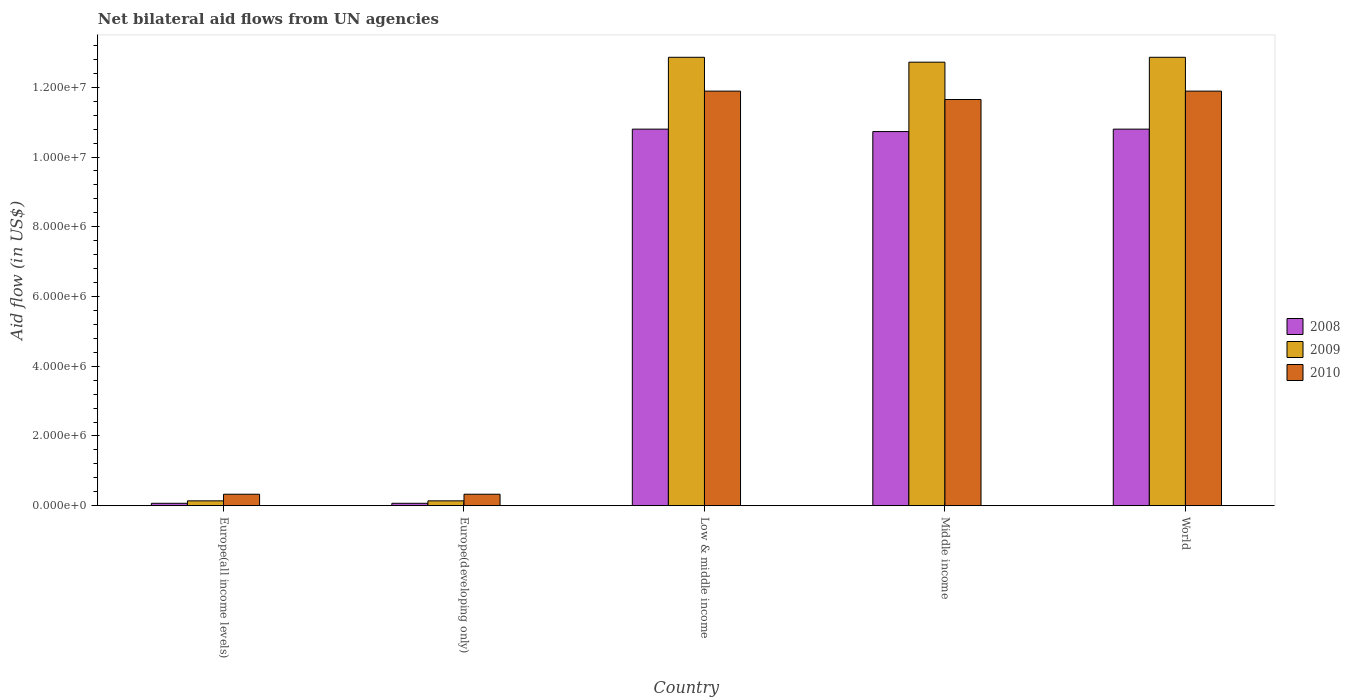How many different coloured bars are there?
Your answer should be compact. 3. How many groups of bars are there?
Ensure brevity in your answer.  5. Are the number of bars on each tick of the X-axis equal?
Ensure brevity in your answer.  Yes. What is the label of the 1st group of bars from the left?
Ensure brevity in your answer.  Europe(all income levels). In how many cases, is the number of bars for a given country not equal to the number of legend labels?
Offer a very short reply. 0. Across all countries, what is the maximum net bilateral aid flow in 2009?
Provide a succinct answer. 1.29e+07. In which country was the net bilateral aid flow in 2008 minimum?
Make the answer very short. Europe(all income levels). What is the total net bilateral aid flow in 2008 in the graph?
Ensure brevity in your answer.  3.25e+07. What is the difference between the net bilateral aid flow in 2008 in Europe(developing only) and that in World?
Keep it short and to the point. -1.07e+07. What is the difference between the net bilateral aid flow in 2010 in World and the net bilateral aid flow in 2008 in Europe(all income levels)?
Give a very brief answer. 1.18e+07. What is the average net bilateral aid flow in 2009 per country?
Your answer should be very brief. 7.74e+06. What is the difference between the net bilateral aid flow of/in 2010 and net bilateral aid flow of/in 2009 in World?
Provide a short and direct response. -9.70e+05. What is the ratio of the net bilateral aid flow in 2008 in Europe(developing only) to that in World?
Offer a terse response. 0.01. Is the net bilateral aid flow in 2010 in Low & middle income less than that in Middle income?
Ensure brevity in your answer.  No. What is the difference between the highest and the lowest net bilateral aid flow in 2010?
Provide a short and direct response. 1.16e+07. How many countries are there in the graph?
Ensure brevity in your answer.  5. What is the difference between two consecutive major ticks on the Y-axis?
Provide a short and direct response. 2.00e+06. Does the graph contain any zero values?
Offer a terse response. No. Does the graph contain grids?
Keep it short and to the point. No. Where does the legend appear in the graph?
Your answer should be very brief. Center right. How are the legend labels stacked?
Keep it short and to the point. Vertical. What is the title of the graph?
Your answer should be very brief. Net bilateral aid flows from UN agencies. Does "1962" appear as one of the legend labels in the graph?
Provide a short and direct response. No. What is the label or title of the Y-axis?
Ensure brevity in your answer.  Aid flow (in US$). What is the Aid flow (in US$) of 2008 in Europe(all income levels)?
Provide a short and direct response. 7.00e+04. What is the Aid flow (in US$) in 2010 in Europe(all income levels)?
Offer a terse response. 3.30e+05. What is the Aid flow (in US$) in 2008 in Europe(developing only)?
Your response must be concise. 7.00e+04. What is the Aid flow (in US$) of 2009 in Europe(developing only)?
Your answer should be very brief. 1.40e+05. What is the Aid flow (in US$) of 2010 in Europe(developing only)?
Offer a terse response. 3.30e+05. What is the Aid flow (in US$) in 2008 in Low & middle income?
Provide a succinct answer. 1.08e+07. What is the Aid flow (in US$) in 2009 in Low & middle income?
Keep it short and to the point. 1.29e+07. What is the Aid flow (in US$) of 2010 in Low & middle income?
Ensure brevity in your answer.  1.19e+07. What is the Aid flow (in US$) in 2008 in Middle income?
Provide a short and direct response. 1.07e+07. What is the Aid flow (in US$) of 2009 in Middle income?
Provide a succinct answer. 1.27e+07. What is the Aid flow (in US$) in 2010 in Middle income?
Make the answer very short. 1.16e+07. What is the Aid flow (in US$) in 2008 in World?
Your response must be concise. 1.08e+07. What is the Aid flow (in US$) in 2009 in World?
Offer a very short reply. 1.29e+07. What is the Aid flow (in US$) of 2010 in World?
Offer a very short reply. 1.19e+07. Across all countries, what is the maximum Aid flow (in US$) in 2008?
Keep it short and to the point. 1.08e+07. Across all countries, what is the maximum Aid flow (in US$) of 2009?
Your response must be concise. 1.29e+07. Across all countries, what is the maximum Aid flow (in US$) of 2010?
Provide a succinct answer. 1.19e+07. Across all countries, what is the minimum Aid flow (in US$) in 2010?
Offer a very short reply. 3.30e+05. What is the total Aid flow (in US$) in 2008 in the graph?
Provide a short and direct response. 3.25e+07. What is the total Aid flow (in US$) of 2009 in the graph?
Make the answer very short. 3.87e+07. What is the total Aid flow (in US$) in 2010 in the graph?
Provide a short and direct response. 3.61e+07. What is the difference between the Aid flow (in US$) of 2008 in Europe(all income levels) and that in Europe(developing only)?
Keep it short and to the point. 0. What is the difference between the Aid flow (in US$) in 2008 in Europe(all income levels) and that in Low & middle income?
Give a very brief answer. -1.07e+07. What is the difference between the Aid flow (in US$) in 2009 in Europe(all income levels) and that in Low & middle income?
Your answer should be compact. -1.27e+07. What is the difference between the Aid flow (in US$) of 2010 in Europe(all income levels) and that in Low & middle income?
Offer a very short reply. -1.16e+07. What is the difference between the Aid flow (in US$) of 2008 in Europe(all income levels) and that in Middle income?
Your answer should be compact. -1.07e+07. What is the difference between the Aid flow (in US$) of 2009 in Europe(all income levels) and that in Middle income?
Your answer should be compact. -1.26e+07. What is the difference between the Aid flow (in US$) of 2010 in Europe(all income levels) and that in Middle income?
Provide a succinct answer. -1.13e+07. What is the difference between the Aid flow (in US$) in 2008 in Europe(all income levels) and that in World?
Offer a very short reply. -1.07e+07. What is the difference between the Aid flow (in US$) in 2009 in Europe(all income levels) and that in World?
Ensure brevity in your answer.  -1.27e+07. What is the difference between the Aid flow (in US$) of 2010 in Europe(all income levels) and that in World?
Provide a short and direct response. -1.16e+07. What is the difference between the Aid flow (in US$) in 2008 in Europe(developing only) and that in Low & middle income?
Your answer should be very brief. -1.07e+07. What is the difference between the Aid flow (in US$) of 2009 in Europe(developing only) and that in Low & middle income?
Offer a very short reply. -1.27e+07. What is the difference between the Aid flow (in US$) in 2010 in Europe(developing only) and that in Low & middle income?
Your response must be concise. -1.16e+07. What is the difference between the Aid flow (in US$) in 2008 in Europe(developing only) and that in Middle income?
Offer a very short reply. -1.07e+07. What is the difference between the Aid flow (in US$) in 2009 in Europe(developing only) and that in Middle income?
Provide a succinct answer. -1.26e+07. What is the difference between the Aid flow (in US$) in 2010 in Europe(developing only) and that in Middle income?
Your response must be concise. -1.13e+07. What is the difference between the Aid flow (in US$) of 2008 in Europe(developing only) and that in World?
Keep it short and to the point. -1.07e+07. What is the difference between the Aid flow (in US$) of 2009 in Europe(developing only) and that in World?
Your answer should be very brief. -1.27e+07. What is the difference between the Aid flow (in US$) of 2010 in Europe(developing only) and that in World?
Make the answer very short. -1.16e+07. What is the difference between the Aid flow (in US$) in 2008 in Low & middle income and that in World?
Provide a succinct answer. 0. What is the difference between the Aid flow (in US$) in 2009 in Low & middle income and that in World?
Keep it short and to the point. 0. What is the difference between the Aid flow (in US$) of 2008 in Middle income and that in World?
Ensure brevity in your answer.  -7.00e+04. What is the difference between the Aid flow (in US$) in 2009 in Middle income and that in World?
Your response must be concise. -1.40e+05. What is the difference between the Aid flow (in US$) of 2010 in Middle income and that in World?
Make the answer very short. -2.40e+05. What is the difference between the Aid flow (in US$) in 2008 in Europe(all income levels) and the Aid flow (in US$) in 2009 in Europe(developing only)?
Provide a short and direct response. -7.00e+04. What is the difference between the Aid flow (in US$) in 2009 in Europe(all income levels) and the Aid flow (in US$) in 2010 in Europe(developing only)?
Provide a succinct answer. -1.90e+05. What is the difference between the Aid flow (in US$) of 2008 in Europe(all income levels) and the Aid flow (in US$) of 2009 in Low & middle income?
Offer a very short reply. -1.28e+07. What is the difference between the Aid flow (in US$) of 2008 in Europe(all income levels) and the Aid flow (in US$) of 2010 in Low & middle income?
Ensure brevity in your answer.  -1.18e+07. What is the difference between the Aid flow (in US$) in 2009 in Europe(all income levels) and the Aid flow (in US$) in 2010 in Low & middle income?
Provide a succinct answer. -1.18e+07. What is the difference between the Aid flow (in US$) in 2008 in Europe(all income levels) and the Aid flow (in US$) in 2009 in Middle income?
Make the answer very short. -1.26e+07. What is the difference between the Aid flow (in US$) of 2008 in Europe(all income levels) and the Aid flow (in US$) of 2010 in Middle income?
Provide a succinct answer. -1.16e+07. What is the difference between the Aid flow (in US$) in 2009 in Europe(all income levels) and the Aid flow (in US$) in 2010 in Middle income?
Provide a succinct answer. -1.15e+07. What is the difference between the Aid flow (in US$) in 2008 in Europe(all income levels) and the Aid flow (in US$) in 2009 in World?
Provide a short and direct response. -1.28e+07. What is the difference between the Aid flow (in US$) of 2008 in Europe(all income levels) and the Aid flow (in US$) of 2010 in World?
Provide a succinct answer. -1.18e+07. What is the difference between the Aid flow (in US$) of 2009 in Europe(all income levels) and the Aid flow (in US$) of 2010 in World?
Give a very brief answer. -1.18e+07. What is the difference between the Aid flow (in US$) in 2008 in Europe(developing only) and the Aid flow (in US$) in 2009 in Low & middle income?
Give a very brief answer. -1.28e+07. What is the difference between the Aid flow (in US$) of 2008 in Europe(developing only) and the Aid flow (in US$) of 2010 in Low & middle income?
Ensure brevity in your answer.  -1.18e+07. What is the difference between the Aid flow (in US$) in 2009 in Europe(developing only) and the Aid flow (in US$) in 2010 in Low & middle income?
Your answer should be very brief. -1.18e+07. What is the difference between the Aid flow (in US$) in 2008 in Europe(developing only) and the Aid flow (in US$) in 2009 in Middle income?
Provide a short and direct response. -1.26e+07. What is the difference between the Aid flow (in US$) in 2008 in Europe(developing only) and the Aid flow (in US$) in 2010 in Middle income?
Give a very brief answer. -1.16e+07. What is the difference between the Aid flow (in US$) in 2009 in Europe(developing only) and the Aid flow (in US$) in 2010 in Middle income?
Make the answer very short. -1.15e+07. What is the difference between the Aid flow (in US$) in 2008 in Europe(developing only) and the Aid flow (in US$) in 2009 in World?
Offer a very short reply. -1.28e+07. What is the difference between the Aid flow (in US$) in 2008 in Europe(developing only) and the Aid flow (in US$) in 2010 in World?
Keep it short and to the point. -1.18e+07. What is the difference between the Aid flow (in US$) in 2009 in Europe(developing only) and the Aid flow (in US$) in 2010 in World?
Your answer should be compact. -1.18e+07. What is the difference between the Aid flow (in US$) of 2008 in Low & middle income and the Aid flow (in US$) of 2009 in Middle income?
Provide a short and direct response. -1.92e+06. What is the difference between the Aid flow (in US$) of 2008 in Low & middle income and the Aid flow (in US$) of 2010 in Middle income?
Provide a short and direct response. -8.50e+05. What is the difference between the Aid flow (in US$) of 2009 in Low & middle income and the Aid flow (in US$) of 2010 in Middle income?
Provide a succinct answer. 1.21e+06. What is the difference between the Aid flow (in US$) of 2008 in Low & middle income and the Aid flow (in US$) of 2009 in World?
Your answer should be very brief. -2.06e+06. What is the difference between the Aid flow (in US$) in 2008 in Low & middle income and the Aid flow (in US$) in 2010 in World?
Provide a short and direct response. -1.09e+06. What is the difference between the Aid flow (in US$) of 2009 in Low & middle income and the Aid flow (in US$) of 2010 in World?
Your response must be concise. 9.70e+05. What is the difference between the Aid flow (in US$) of 2008 in Middle income and the Aid flow (in US$) of 2009 in World?
Your answer should be very brief. -2.13e+06. What is the difference between the Aid flow (in US$) in 2008 in Middle income and the Aid flow (in US$) in 2010 in World?
Keep it short and to the point. -1.16e+06. What is the difference between the Aid flow (in US$) of 2009 in Middle income and the Aid flow (in US$) of 2010 in World?
Ensure brevity in your answer.  8.30e+05. What is the average Aid flow (in US$) in 2008 per country?
Provide a short and direct response. 6.49e+06. What is the average Aid flow (in US$) of 2009 per country?
Give a very brief answer. 7.74e+06. What is the average Aid flow (in US$) of 2010 per country?
Your answer should be compact. 7.22e+06. What is the difference between the Aid flow (in US$) of 2008 and Aid flow (in US$) of 2010 in Europe(all income levels)?
Ensure brevity in your answer.  -2.60e+05. What is the difference between the Aid flow (in US$) in 2008 and Aid flow (in US$) in 2010 in Europe(developing only)?
Provide a succinct answer. -2.60e+05. What is the difference between the Aid flow (in US$) of 2009 and Aid flow (in US$) of 2010 in Europe(developing only)?
Offer a very short reply. -1.90e+05. What is the difference between the Aid flow (in US$) of 2008 and Aid flow (in US$) of 2009 in Low & middle income?
Offer a very short reply. -2.06e+06. What is the difference between the Aid flow (in US$) of 2008 and Aid flow (in US$) of 2010 in Low & middle income?
Ensure brevity in your answer.  -1.09e+06. What is the difference between the Aid flow (in US$) in 2009 and Aid flow (in US$) in 2010 in Low & middle income?
Offer a terse response. 9.70e+05. What is the difference between the Aid flow (in US$) of 2008 and Aid flow (in US$) of 2009 in Middle income?
Your response must be concise. -1.99e+06. What is the difference between the Aid flow (in US$) in 2008 and Aid flow (in US$) in 2010 in Middle income?
Provide a succinct answer. -9.20e+05. What is the difference between the Aid flow (in US$) in 2009 and Aid flow (in US$) in 2010 in Middle income?
Your answer should be very brief. 1.07e+06. What is the difference between the Aid flow (in US$) of 2008 and Aid flow (in US$) of 2009 in World?
Your answer should be very brief. -2.06e+06. What is the difference between the Aid flow (in US$) of 2008 and Aid flow (in US$) of 2010 in World?
Offer a very short reply. -1.09e+06. What is the difference between the Aid flow (in US$) of 2009 and Aid flow (in US$) of 2010 in World?
Provide a short and direct response. 9.70e+05. What is the ratio of the Aid flow (in US$) of 2010 in Europe(all income levels) to that in Europe(developing only)?
Offer a terse response. 1. What is the ratio of the Aid flow (in US$) of 2008 in Europe(all income levels) to that in Low & middle income?
Provide a succinct answer. 0.01. What is the ratio of the Aid flow (in US$) of 2009 in Europe(all income levels) to that in Low & middle income?
Offer a terse response. 0.01. What is the ratio of the Aid flow (in US$) in 2010 in Europe(all income levels) to that in Low & middle income?
Make the answer very short. 0.03. What is the ratio of the Aid flow (in US$) of 2008 in Europe(all income levels) to that in Middle income?
Your answer should be very brief. 0.01. What is the ratio of the Aid flow (in US$) in 2009 in Europe(all income levels) to that in Middle income?
Keep it short and to the point. 0.01. What is the ratio of the Aid flow (in US$) in 2010 in Europe(all income levels) to that in Middle income?
Make the answer very short. 0.03. What is the ratio of the Aid flow (in US$) in 2008 in Europe(all income levels) to that in World?
Your answer should be compact. 0.01. What is the ratio of the Aid flow (in US$) of 2009 in Europe(all income levels) to that in World?
Make the answer very short. 0.01. What is the ratio of the Aid flow (in US$) of 2010 in Europe(all income levels) to that in World?
Make the answer very short. 0.03. What is the ratio of the Aid flow (in US$) of 2008 in Europe(developing only) to that in Low & middle income?
Offer a terse response. 0.01. What is the ratio of the Aid flow (in US$) in 2009 in Europe(developing only) to that in Low & middle income?
Provide a short and direct response. 0.01. What is the ratio of the Aid flow (in US$) in 2010 in Europe(developing only) to that in Low & middle income?
Keep it short and to the point. 0.03. What is the ratio of the Aid flow (in US$) of 2008 in Europe(developing only) to that in Middle income?
Your response must be concise. 0.01. What is the ratio of the Aid flow (in US$) of 2009 in Europe(developing only) to that in Middle income?
Your answer should be very brief. 0.01. What is the ratio of the Aid flow (in US$) of 2010 in Europe(developing only) to that in Middle income?
Ensure brevity in your answer.  0.03. What is the ratio of the Aid flow (in US$) of 2008 in Europe(developing only) to that in World?
Make the answer very short. 0.01. What is the ratio of the Aid flow (in US$) in 2009 in Europe(developing only) to that in World?
Provide a short and direct response. 0.01. What is the ratio of the Aid flow (in US$) in 2010 in Europe(developing only) to that in World?
Your answer should be compact. 0.03. What is the ratio of the Aid flow (in US$) in 2010 in Low & middle income to that in Middle income?
Give a very brief answer. 1.02. What is the ratio of the Aid flow (in US$) of 2008 in Low & middle income to that in World?
Keep it short and to the point. 1. What is the ratio of the Aid flow (in US$) in 2008 in Middle income to that in World?
Make the answer very short. 0.99. What is the ratio of the Aid flow (in US$) of 2010 in Middle income to that in World?
Offer a very short reply. 0.98. What is the difference between the highest and the second highest Aid flow (in US$) of 2008?
Your answer should be very brief. 0. What is the difference between the highest and the lowest Aid flow (in US$) in 2008?
Give a very brief answer. 1.07e+07. What is the difference between the highest and the lowest Aid flow (in US$) in 2009?
Provide a short and direct response. 1.27e+07. What is the difference between the highest and the lowest Aid flow (in US$) in 2010?
Ensure brevity in your answer.  1.16e+07. 